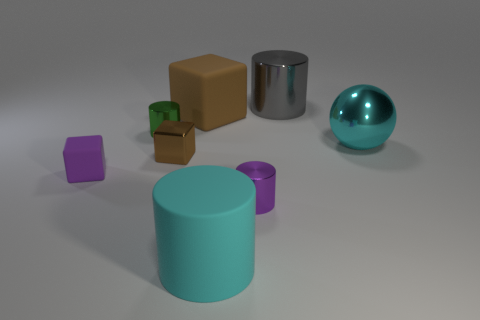What is the purple cube made of?
Offer a very short reply. Rubber. Does the small purple rubber thing have the same shape as the gray thing?
Your response must be concise. No. Is there a yellow cylinder that has the same material as the large gray thing?
Provide a short and direct response. No. What is the color of the rubber thing that is both on the left side of the large matte cylinder and in front of the big brown rubber cube?
Provide a short and direct response. Purple. There is a cyan object on the right side of the tiny purple metal cylinder; what material is it?
Make the answer very short. Metal. Is there a small brown shiny object of the same shape as the green thing?
Keep it short and to the point. No. What number of other things are the same shape as the cyan shiny thing?
Your response must be concise. 0. There is a gray thing; is it the same shape as the tiny purple object that is on the right side of the green shiny cylinder?
Your answer should be compact. Yes. There is a cyan thing that is the same shape as the big gray metallic object; what material is it?
Offer a terse response. Rubber. What number of large objects are purple matte blocks or red metallic spheres?
Keep it short and to the point. 0. 